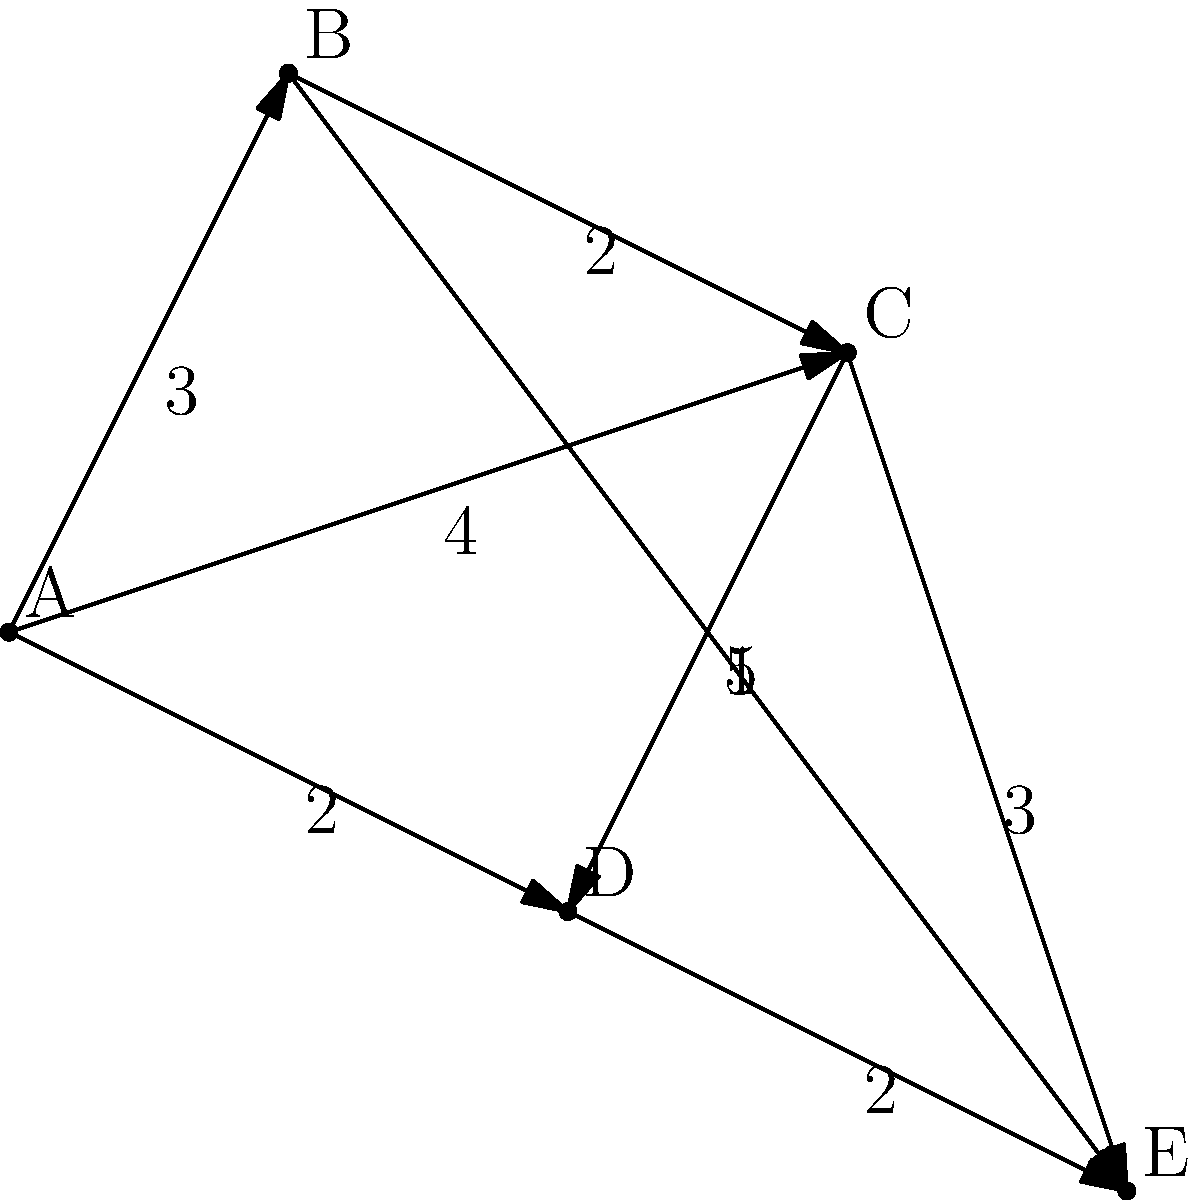As a delivery coordinator for Christmas packages in Petawawa, you need to find the most efficient route from point A (the distribution center) to point E (the final delivery location). What is the shortest total distance to reach point E from point A? To find the shortest path from A to E, we'll use Dijkstra's algorithm:

1. Initialize:
   - Distance to A: 0
   - Distance to all other nodes: ∞

2. Visit A:
   - Update B: min(∞, 0 + 3) = 3
   - Update C: min(∞, 0 + 4) = 4
   - Update D: min(∞, 0 + 2) = 2

3. Visit D (closest unvisited node):
   - Update C: min(4, 2 + 1) = 3
   - Update E: min(∞, 2 + 2) = 4

4. Visit B:
   - Update C: min(3, 3 + 2) = 3
   - Update E: min(4, 3 + 5) = 4

5. Visit C:
   - Update E: min(4, 3 + 3) = 4

6. Visit E (destination reached)

The shortest path is A -> D -> E with a total distance of 4.
Answer: 4 units 